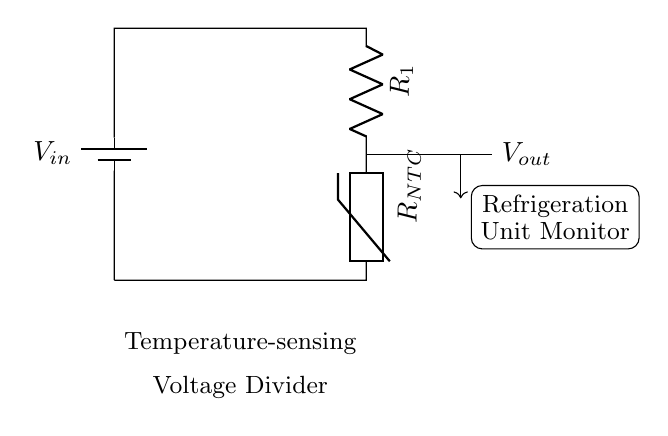What is the input voltage of this circuit? The input voltage is labeled \( V_{in} \) in the circuit diagram, indicating the voltage supplied to the voltage divider circuit.
Answer: \( V_{in} \) What components are used in this voltage divider? The components in this circuit are a battery (for input voltage), a resistor labeled \( R_1 \), and a thermistor labeled \( R_{NTC} \).
Answer: Battery, \( R_1 \), \( R_{NTC} \) What is the purpose of the thermistor in the circuit? The thermistor \( R_{NTC} \) serves as a temperature sensor; it changes resistance with temperature, allowing the voltage output to correspond to the temperature being monitored.
Answer: Temperature sensor What happens to \( V_{out} \) as the temperature increases? As temperature increases, the resistance of the NTC thermistor decreases, causing an increase in \( V_{out} \) according to the voltage divider principle.
Answer: Increases What is the relationship between \( R_1 \) and the output voltage? \( V_{out} \) is inversely related to the value of \( R_1 \) since a higher \( R_1 \) value means a smaller proportion of the input voltage is dropped across \( R_{NTC} \), lowering \( V_{out} \).
Answer: Inversely related How does this circuit monitor refrigeration units? The circuit outputs a voltage proportional to the temperature inside the refrigeration unit; this voltage can be monitored to determine if the temperature is within desired limits.
Answer: Monitors temperature 